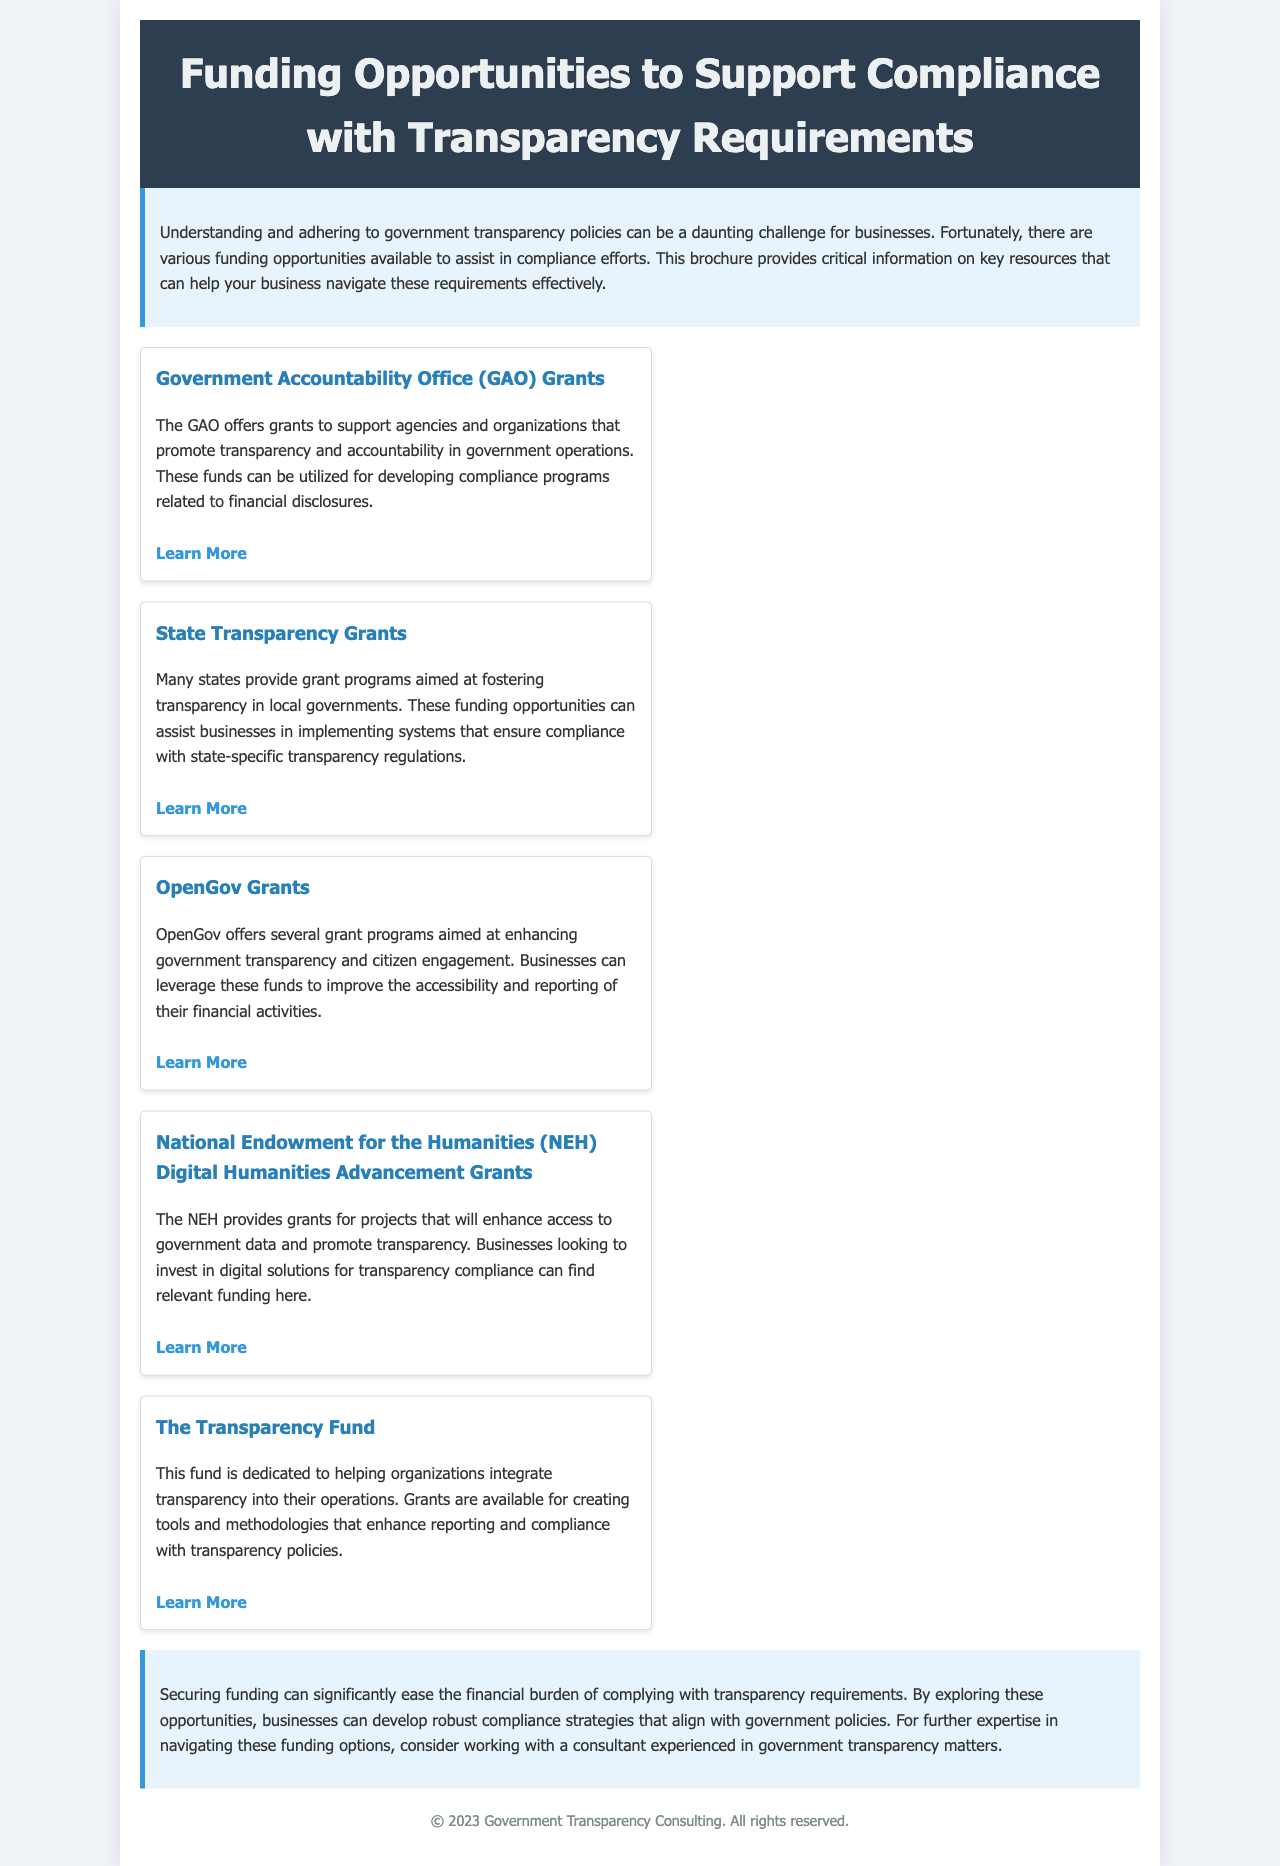What is the title of the brochure? The title is the main heading of the document and says what the brochure is about.
Answer: Funding Opportunities to Support Compliance with Transparency Requirements What does GAO stand for? The acronym is mentioned in the context of grants provided by a specific organization.
Answer: Government Accountability Office How many types of grants are mentioned in the brochure? The answer can be derived from counting the distinct grant opportunities listed.
Answer: Five Which organization provides grants specifically for digital solutions? This organization is highlighted for its focus on enhancing access to government data through digital means.
Answer: National Endowment for the Humanities What is the purpose of The Transparency Fund? The purpose is stated clearly in the description of this funding opportunity within the document.
Answer: Integrate transparency into operations What is the color theme of the brochure? The color scheme can be inferred from the descriptions of various sections and the general design.
Answer: Blue and white Which grant focuses on citizen engagement? This grant is specifically aimed at enhancing government transparency and interaction with citizens.
Answer: OpenGov Grants What type of information can businesses receive funding for according to the brochure? This refers to the general outcome or goals businesses can achieve with the funding opportunities outlined.
Answer: Compliance with transparency regulations What is the main benefit of securing funding as described in the conclusion? The conclusion provides insight into the advantages of obtaining funding related to compliance efforts.
Answer: Ease the financial burden 